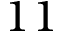<formula> <loc_0><loc_0><loc_500><loc_500>1 1</formula> 